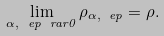Convert formula to latex. <formula><loc_0><loc_0><loc_500><loc_500>\lim _ { \alpha , \ e p \ r a r 0 } \rho _ { \alpha , \ e p } = \rho .</formula> 